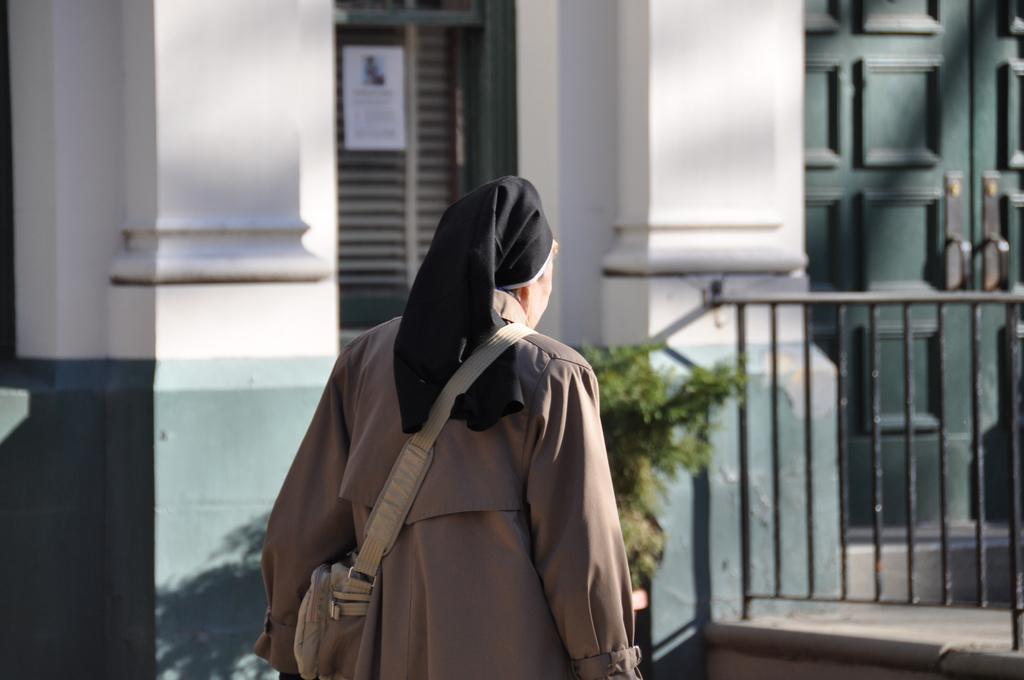How would you summarize this image in a sentence or two? There is a woman wearing brown dress and carrying a bag and there is a building and a plant beside her. 